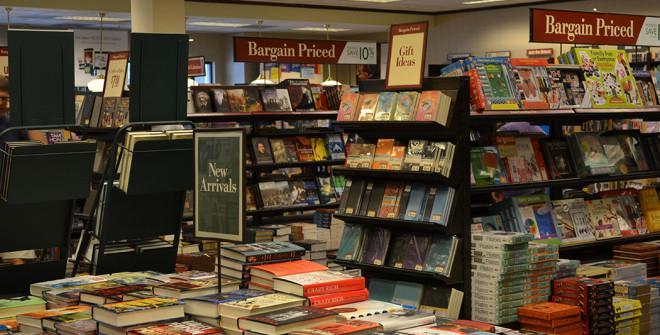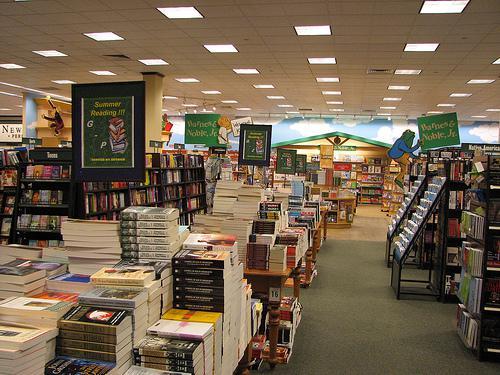The first image is the image on the left, the second image is the image on the right. For the images displayed, is the sentence "There is exactly one person." factually correct? Answer yes or no. No. The first image is the image on the left, the second image is the image on the right. Analyze the images presented: Is the assertion "Someone is standing while reading a book." valid? Answer yes or no. No. 